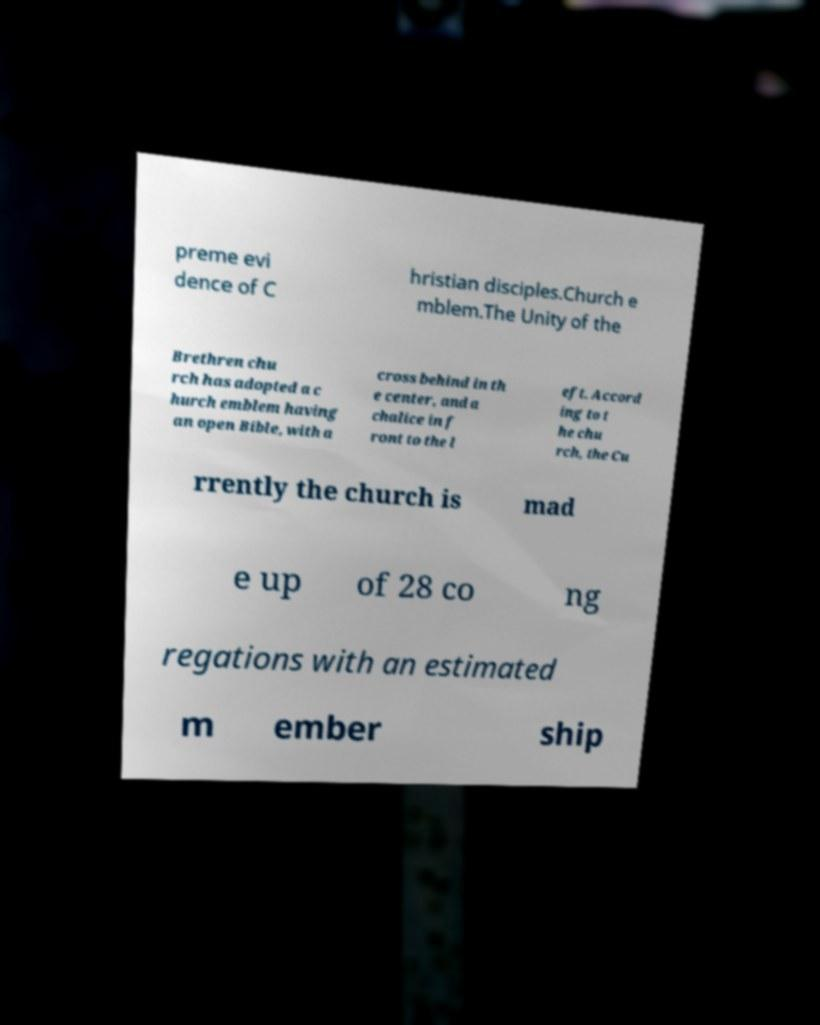What messages or text are displayed in this image? I need them in a readable, typed format. preme evi dence of C hristian disciples.Church e mblem.The Unity of the Brethren chu rch has adopted a c hurch emblem having an open Bible, with a cross behind in th e center, and a chalice in f ront to the l eft. Accord ing to t he chu rch, the Cu rrently the church is mad e up of 28 co ng regations with an estimated m ember ship 